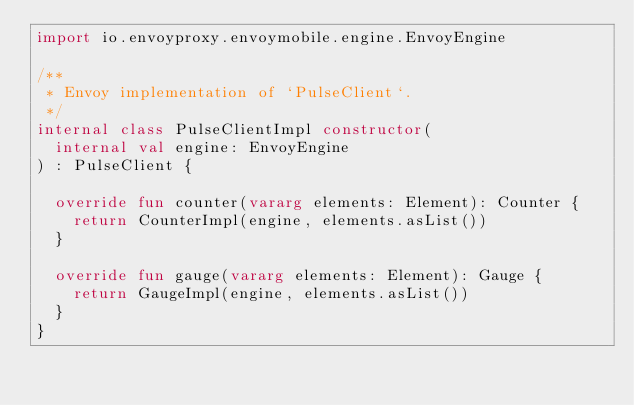<code> <loc_0><loc_0><loc_500><loc_500><_Kotlin_>import io.envoyproxy.envoymobile.engine.EnvoyEngine

/**
 * Envoy implementation of `PulseClient`.
 */
internal class PulseClientImpl constructor(
  internal val engine: EnvoyEngine
) : PulseClient {

  override fun counter(vararg elements: Element): Counter {
    return CounterImpl(engine, elements.asList())
  }

  override fun gauge(vararg elements: Element): Gauge {
    return GaugeImpl(engine, elements.asList())
  }
}
</code> 